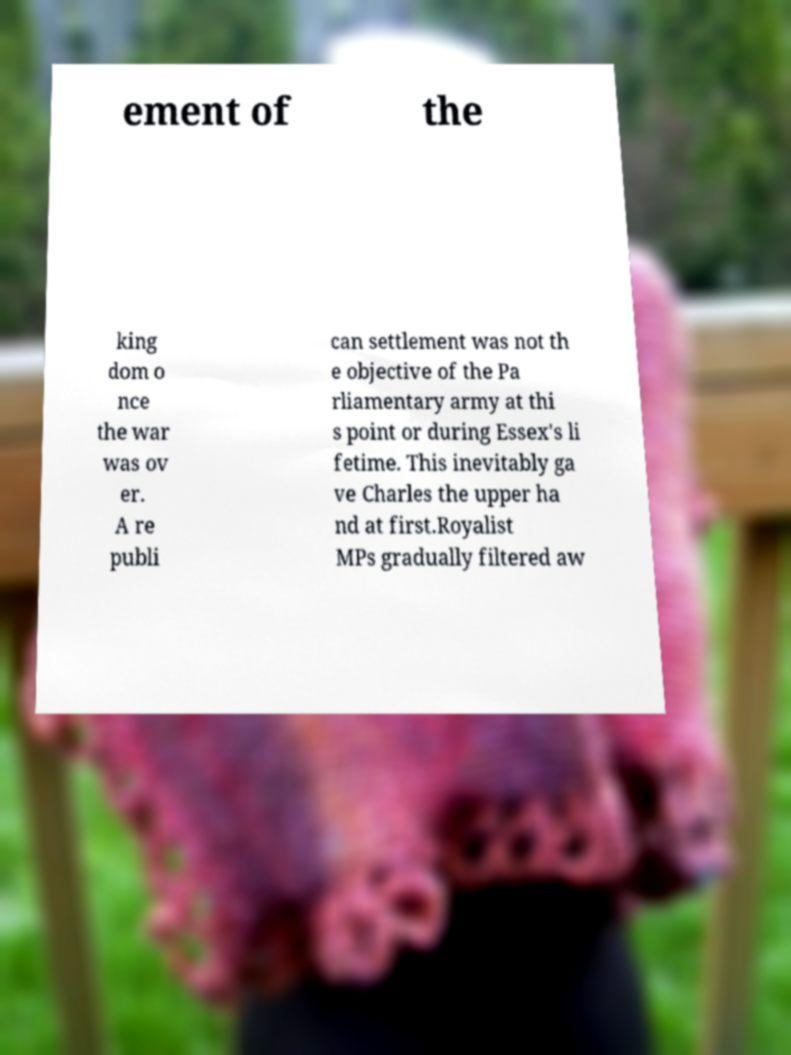Can you read and provide the text displayed in the image?This photo seems to have some interesting text. Can you extract and type it out for me? ement of the king dom o nce the war was ov er. A re publi can settlement was not th e objective of the Pa rliamentary army at thi s point or during Essex's li fetime. This inevitably ga ve Charles the upper ha nd at first.Royalist MPs gradually filtered aw 